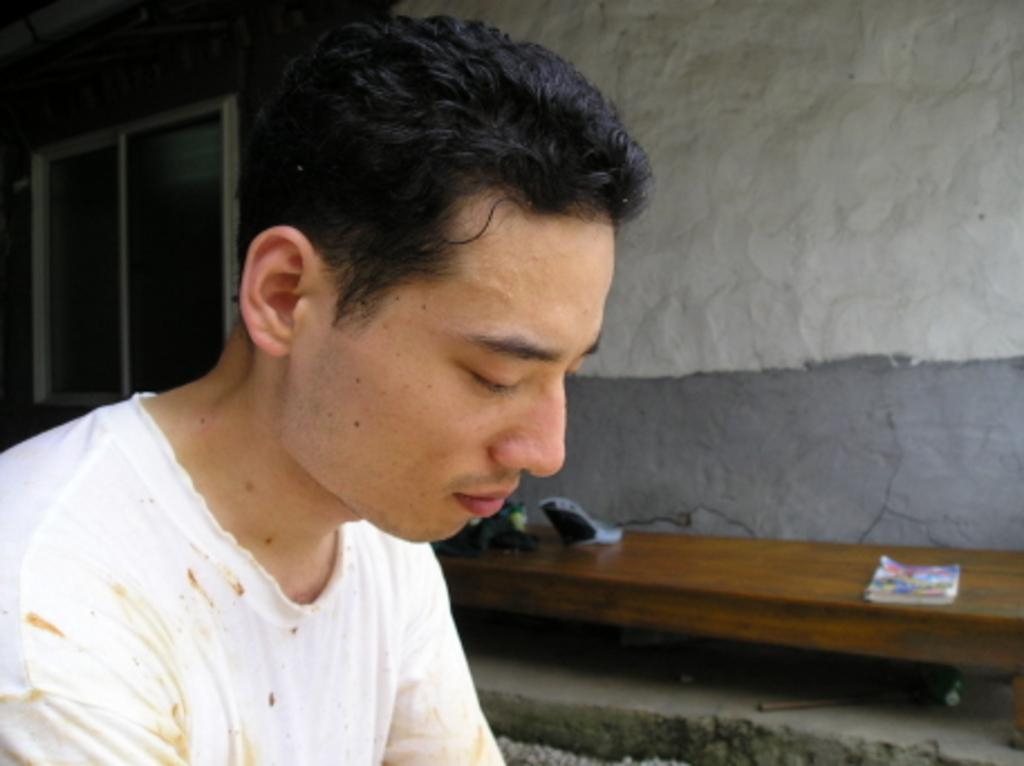Who is the main subject in the image? There is a boy in the image. Where is the boy located in the image? The boy is on the left side of the image. What is another object visible in the image? There is a bench in the image. Where is the bench located in the image? The bench is on the right side of the image. What can be seen behind the boy on the left side of the image? There is a window in the image. What type of bread is the boy holding in the image? There is no bread present in the image. Is the boy accompanied by a pet in the image? There is no pet visible in the image. 